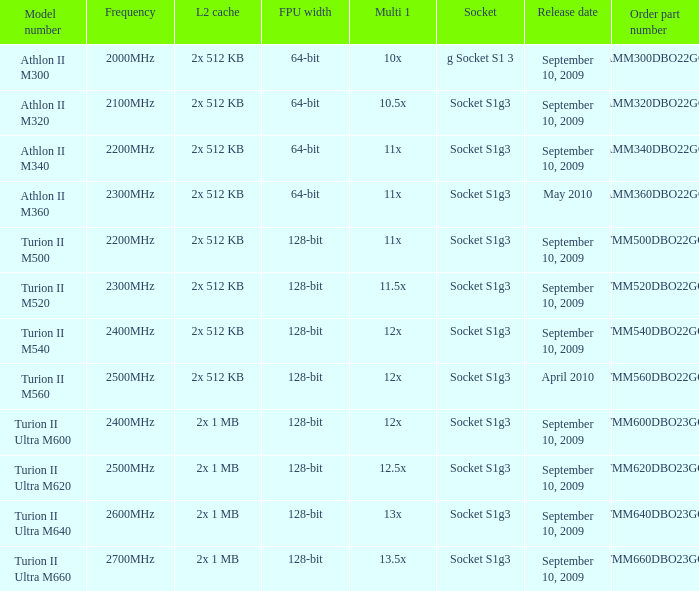5x multiplication factor 1? 2x 1 MB. 